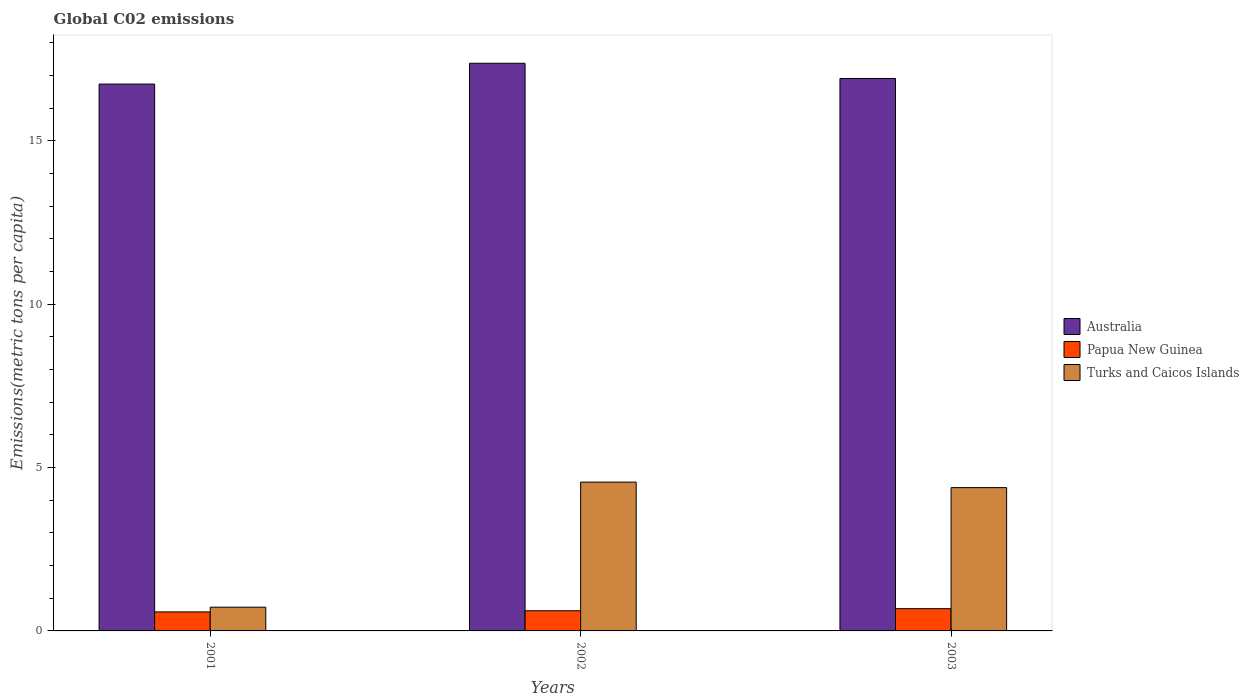How many different coloured bars are there?
Offer a very short reply. 3. Are the number of bars on each tick of the X-axis equal?
Provide a short and direct response. Yes. What is the label of the 1st group of bars from the left?
Your answer should be compact. 2001. What is the amount of CO2 emitted in in Turks and Caicos Islands in 2003?
Provide a succinct answer. 4.39. Across all years, what is the maximum amount of CO2 emitted in in Australia?
Provide a succinct answer. 17.37. Across all years, what is the minimum amount of CO2 emitted in in Australia?
Your answer should be compact. 16.74. In which year was the amount of CO2 emitted in in Papua New Guinea maximum?
Offer a very short reply. 2003. In which year was the amount of CO2 emitted in in Australia minimum?
Offer a very short reply. 2001. What is the total amount of CO2 emitted in in Papua New Guinea in the graph?
Give a very brief answer. 1.88. What is the difference between the amount of CO2 emitted in in Papua New Guinea in 2001 and that in 2002?
Provide a short and direct response. -0.03. What is the difference between the amount of CO2 emitted in in Papua New Guinea in 2003 and the amount of CO2 emitted in in Australia in 2001?
Make the answer very short. -16.05. What is the average amount of CO2 emitted in in Turks and Caicos Islands per year?
Provide a short and direct response. 3.22. In the year 2002, what is the difference between the amount of CO2 emitted in in Papua New Guinea and amount of CO2 emitted in in Turks and Caicos Islands?
Offer a very short reply. -3.94. What is the ratio of the amount of CO2 emitted in in Turks and Caicos Islands in 2001 to that in 2003?
Keep it short and to the point. 0.17. Is the difference between the amount of CO2 emitted in in Papua New Guinea in 2002 and 2003 greater than the difference between the amount of CO2 emitted in in Turks and Caicos Islands in 2002 and 2003?
Your answer should be very brief. No. What is the difference between the highest and the second highest amount of CO2 emitted in in Turks and Caicos Islands?
Ensure brevity in your answer.  0.17. What is the difference between the highest and the lowest amount of CO2 emitted in in Turks and Caicos Islands?
Make the answer very short. 3.83. In how many years, is the amount of CO2 emitted in in Papua New Guinea greater than the average amount of CO2 emitted in in Papua New Guinea taken over all years?
Your response must be concise. 1. Is the sum of the amount of CO2 emitted in in Papua New Guinea in 2002 and 2003 greater than the maximum amount of CO2 emitted in in Australia across all years?
Your answer should be very brief. No. What does the 2nd bar from the left in 2001 represents?
Provide a short and direct response. Papua New Guinea. What does the 2nd bar from the right in 2002 represents?
Make the answer very short. Papua New Guinea. Is it the case that in every year, the sum of the amount of CO2 emitted in in Australia and amount of CO2 emitted in in Papua New Guinea is greater than the amount of CO2 emitted in in Turks and Caicos Islands?
Provide a short and direct response. Yes. How many bars are there?
Offer a very short reply. 9. How many years are there in the graph?
Your response must be concise. 3. What is the difference between two consecutive major ticks on the Y-axis?
Provide a short and direct response. 5. Does the graph contain any zero values?
Your answer should be very brief. No. Where does the legend appear in the graph?
Make the answer very short. Center right. How many legend labels are there?
Keep it short and to the point. 3. What is the title of the graph?
Make the answer very short. Global C02 emissions. What is the label or title of the Y-axis?
Your answer should be very brief. Emissions(metric tons per capita). What is the Emissions(metric tons per capita) in Australia in 2001?
Your answer should be very brief. 16.74. What is the Emissions(metric tons per capita) in Papua New Guinea in 2001?
Your answer should be compact. 0.58. What is the Emissions(metric tons per capita) in Turks and Caicos Islands in 2001?
Ensure brevity in your answer.  0.73. What is the Emissions(metric tons per capita) in Australia in 2002?
Offer a very short reply. 17.37. What is the Emissions(metric tons per capita) of Papua New Guinea in 2002?
Your answer should be very brief. 0.62. What is the Emissions(metric tons per capita) of Turks and Caicos Islands in 2002?
Make the answer very short. 4.55. What is the Emissions(metric tons per capita) in Australia in 2003?
Offer a very short reply. 16.91. What is the Emissions(metric tons per capita) of Papua New Guinea in 2003?
Your answer should be compact. 0.68. What is the Emissions(metric tons per capita) in Turks and Caicos Islands in 2003?
Offer a very short reply. 4.39. Across all years, what is the maximum Emissions(metric tons per capita) in Australia?
Keep it short and to the point. 17.37. Across all years, what is the maximum Emissions(metric tons per capita) in Papua New Guinea?
Your response must be concise. 0.68. Across all years, what is the maximum Emissions(metric tons per capita) in Turks and Caicos Islands?
Make the answer very short. 4.55. Across all years, what is the minimum Emissions(metric tons per capita) of Australia?
Provide a succinct answer. 16.74. Across all years, what is the minimum Emissions(metric tons per capita) of Papua New Guinea?
Your answer should be very brief. 0.58. Across all years, what is the minimum Emissions(metric tons per capita) in Turks and Caicos Islands?
Offer a very short reply. 0.73. What is the total Emissions(metric tons per capita) of Australia in the graph?
Your response must be concise. 51.01. What is the total Emissions(metric tons per capita) of Papua New Guinea in the graph?
Ensure brevity in your answer.  1.88. What is the total Emissions(metric tons per capita) in Turks and Caicos Islands in the graph?
Provide a succinct answer. 9.67. What is the difference between the Emissions(metric tons per capita) in Australia in 2001 and that in 2002?
Provide a short and direct response. -0.64. What is the difference between the Emissions(metric tons per capita) of Papua New Guinea in 2001 and that in 2002?
Your response must be concise. -0.03. What is the difference between the Emissions(metric tons per capita) of Turks and Caicos Islands in 2001 and that in 2002?
Provide a short and direct response. -3.83. What is the difference between the Emissions(metric tons per capita) of Australia in 2001 and that in 2003?
Make the answer very short. -0.17. What is the difference between the Emissions(metric tons per capita) of Papua New Guinea in 2001 and that in 2003?
Make the answer very short. -0.1. What is the difference between the Emissions(metric tons per capita) of Turks and Caicos Islands in 2001 and that in 2003?
Your response must be concise. -3.66. What is the difference between the Emissions(metric tons per capita) of Australia in 2002 and that in 2003?
Your response must be concise. 0.47. What is the difference between the Emissions(metric tons per capita) of Papua New Guinea in 2002 and that in 2003?
Your response must be concise. -0.06. What is the difference between the Emissions(metric tons per capita) in Turks and Caicos Islands in 2002 and that in 2003?
Your answer should be very brief. 0.17. What is the difference between the Emissions(metric tons per capita) of Australia in 2001 and the Emissions(metric tons per capita) of Papua New Guinea in 2002?
Offer a very short reply. 16.12. What is the difference between the Emissions(metric tons per capita) in Australia in 2001 and the Emissions(metric tons per capita) in Turks and Caicos Islands in 2002?
Keep it short and to the point. 12.18. What is the difference between the Emissions(metric tons per capita) in Papua New Guinea in 2001 and the Emissions(metric tons per capita) in Turks and Caicos Islands in 2002?
Provide a short and direct response. -3.97. What is the difference between the Emissions(metric tons per capita) in Australia in 2001 and the Emissions(metric tons per capita) in Papua New Guinea in 2003?
Make the answer very short. 16.05. What is the difference between the Emissions(metric tons per capita) of Australia in 2001 and the Emissions(metric tons per capita) of Turks and Caicos Islands in 2003?
Offer a very short reply. 12.35. What is the difference between the Emissions(metric tons per capita) in Papua New Guinea in 2001 and the Emissions(metric tons per capita) in Turks and Caicos Islands in 2003?
Give a very brief answer. -3.8. What is the difference between the Emissions(metric tons per capita) in Australia in 2002 and the Emissions(metric tons per capita) in Papua New Guinea in 2003?
Provide a short and direct response. 16.69. What is the difference between the Emissions(metric tons per capita) of Australia in 2002 and the Emissions(metric tons per capita) of Turks and Caicos Islands in 2003?
Make the answer very short. 12.99. What is the difference between the Emissions(metric tons per capita) of Papua New Guinea in 2002 and the Emissions(metric tons per capita) of Turks and Caicos Islands in 2003?
Keep it short and to the point. -3.77. What is the average Emissions(metric tons per capita) in Australia per year?
Provide a succinct answer. 17. What is the average Emissions(metric tons per capita) in Papua New Guinea per year?
Give a very brief answer. 0.63. What is the average Emissions(metric tons per capita) in Turks and Caicos Islands per year?
Offer a very short reply. 3.22. In the year 2001, what is the difference between the Emissions(metric tons per capita) in Australia and Emissions(metric tons per capita) in Papua New Guinea?
Your answer should be compact. 16.15. In the year 2001, what is the difference between the Emissions(metric tons per capita) of Australia and Emissions(metric tons per capita) of Turks and Caicos Islands?
Your answer should be very brief. 16.01. In the year 2001, what is the difference between the Emissions(metric tons per capita) in Papua New Guinea and Emissions(metric tons per capita) in Turks and Caicos Islands?
Make the answer very short. -0.14. In the year 2002, what is the difference between the Emissions(metric tons per capita) of Australia and Emissions(metric tons per capita) of Papua New Guinea?
Provide a short and direct response. 16.76. In the year 2002, what is the difference between the Emissions(metric tons per capita) in Australia and Emissions(metric tons per capita) in Turks and Caicos Islands?
Your answer should be compact. 12.82. In the year 2002, what is the difference between the Emissions(metric tons per capita) in Papua New Guinea and Emissions(metric tons per capita) in Turks and Caicos Islands?
Provide a short and direct response. -3.94. In the year 2003, what is the difference between the Emissions(metric tons per capita) of Australia and Emissions(metric tons per capita) of Papua New Guinea?
Provide a short and direct response. 16.23. In the year 2003, what is the difference between the Emissions(metric tons per capita) in Australia and Emissions(metric tons per capita) in Turks and Caicos Islands?
Give a very brief answer. 12.52. In the year 2003, what is the difference between the Emissions(metric tons per capita) in Papua New Guinea and Emissions(metric tons per capita) in Turks and Caicos Islands?
Ensure brevity in your answer.  -3.7. What is the ratio of the Emissions(metric tons per capita) in Australia in 2001 to that in 2002?
Offer a terse response. 0.96. What is the ratio of the Emissions(metric tons per capita) in Papua New Guinea in 2001 to that in 2002?
Make the answer very short. 0.94. What is the ratio of the Emissions(metric tons per capita) of Turks and Caicos Islands in 2001 to that in 2002?
Your answer should be compact. 0.16. What is the ratio of the Emissions(metric tons per capita) of Papua New Guinea in 2001 to that in 2003?
Your answer should be very brief. 0.85. What is the ratio of the Emissions(metric tons per capita) in Turks and Caicos Islands in 2001 to that in 2003?
Your response must be concise. 0.17. What is the ratio of the Emissions(metric tons per capita) in Australia in 2002 to that in 2003?
Your response must be concise. 1.03. What is the ratio of the Emissions(metric tons per capita) of Papua New Guinea in 2002 to that in 2003?
Ensure brevity in your answer.  0.91. What is the ratio of the Emissions(metric tons per capita) of Turks and Caicos Islands in 2002 to that in 2003?
Provide a short and direct response. 1.04. What is the difference between the highest and the second highest Emissions(metric tons per capita) in Australia?
Keep it short and to the point. 0.47. What is the difference between the highest and the second highest Emissions(metric tons per capita) of Papua New Guinea?
Ensure brevity in your answer.  0.06. What is the difference between the highest and the second highest Emissions(metric tons per capita) of Turks and Caicos Islands?
Offer a terse response. 0.17. What is the difference between the highest and the lowest Emissions(metric tons per capita) of Australia?
Keep it short and to the point. 0.64. What is the difference between the highest and the lowest Emissions(metric tons per capita) in Papua New Guinea?
Ensure brevity in your answer.  0.1. What is the difference between the highest and the lowest Emissions(metric tons per capita) in Turks and Caicos Islands?
Your response must be concise. 3.83. 